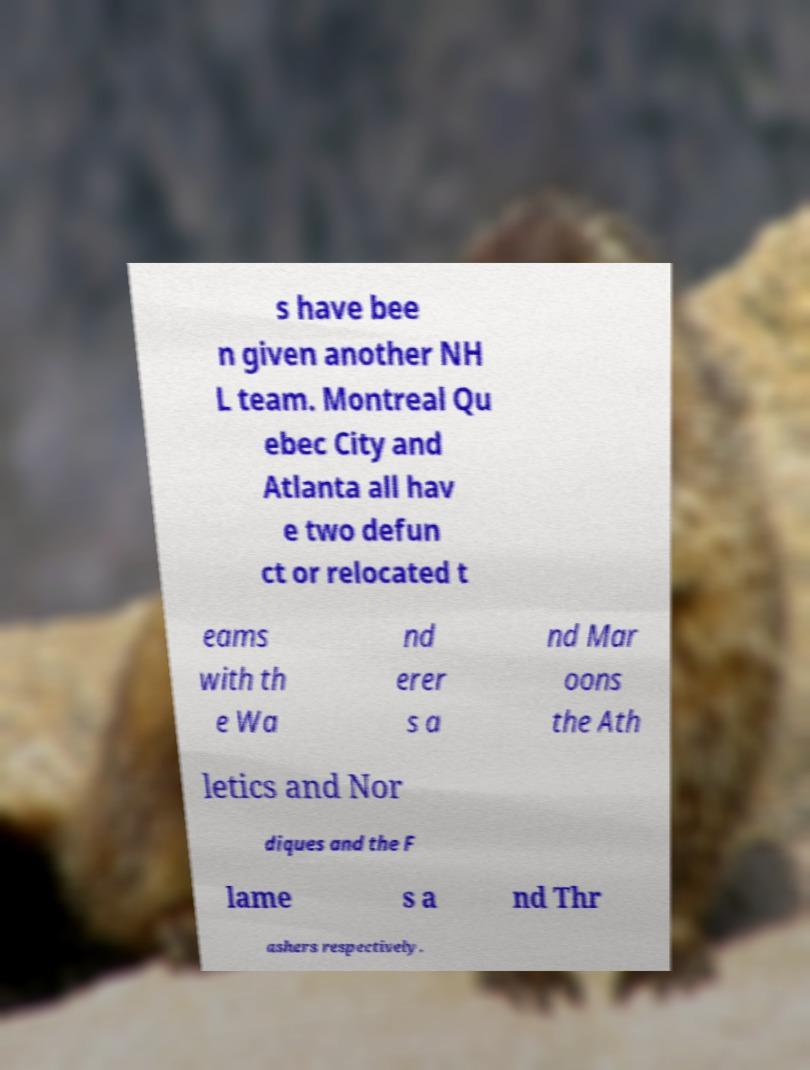Can you accurately transcribe the text from the provided image for me? s have bee n given another NH L team. Montreal Qu ebec City and Atlanta all hav e two defun ct or relocated t eams with th e Wa nd erer s a nd Mar oons the Ath letics and Nor diques and the F lame s a nd Thr ashers respectively. 